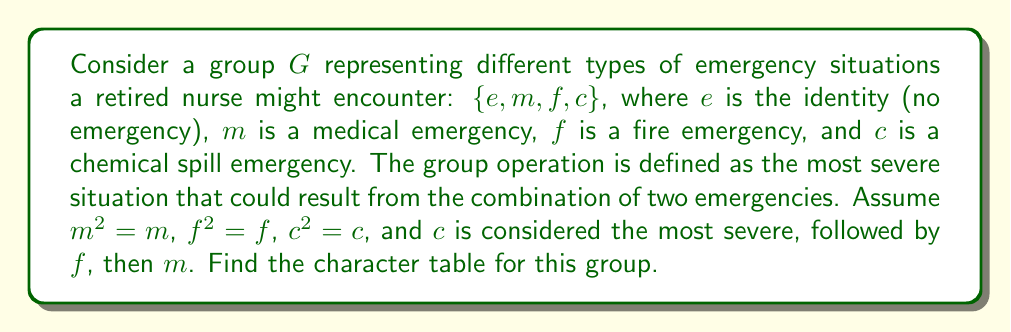What is the answer to this math problem? To find the character table, we'll follow these steps:

1) First, determine the conjugacy classes:
   Since the group is abelian (all elements commute), each element forms its own conjugacy class.
   Conjugacy classes: $\{e\}$, $\{m\}$, $\{f\}$, $\{c\}$

2) The number of irreducible representations equals the number of conjugacy classes, so we have 4 irreducible representations.

3) For an abelian group, all irreducible representations are 1-dimensional.

4) Let's denote the irreducible representations as $\chi_1, \chi_2, \chi_3, \chi_4$.

5) $\chi_1$ is always the trivial representation, assigning 1 to all elements.

6) For the other representations, we need to ensure orthogonality. We can use the complex 4th roots of unity: $1, i, -1, -i$.

7) Construct the character table:

   $$\begin{array}{c|cccc}
      & e & m & f & c \\
   \hline
   \chi_1 & 1 & 1 & 1 & 1 \\
   \chi_2 & 1 & i & -1 & -i \\
   \chi_3 & 1 & -1 & 1 & -1 \\
   \chi_4 & 1 & -i & -1 & i
   \end{array}$$

8) Verify orthogonality:
   For any two different rows $a$ and $b$:
   $\sum_{g \in G} \chi_a(g) \overline{\chi_b(g)} = 0$

   For each row $a$:
   $\sum_{g \in G} |\chi_a(g)|^2 = |G| = 4$

These conditions are satisfied by our character table.
Answer: $$\begin{array}{c|cccc}
   & e & m & f & c \\
\hline
\chi_1 & 1 & 1 & 1 & 1 \\
\chi_2 & 1 & i & -1 & -i \\
\chi_3 & 1 & -1 & 1 & -1 \\
\chi_4 & 1 & -i & -1 & i
\end{array}$$ 